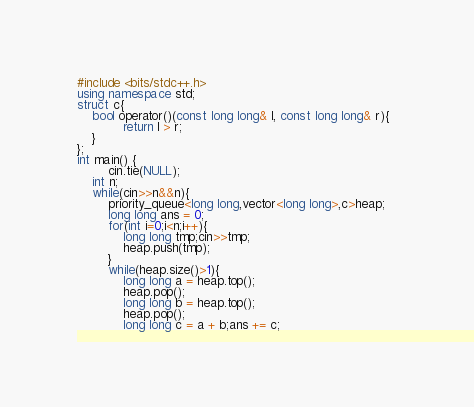<code> <loc_0><loc_0><loc_500><loc_500><_C++_>#include <bits/stdc++.h>
using namespace std;
struct c{
	bool operator()(const long long& l, const long long& r){  
       		return l > r;  
	}
};
int main() {
    	cin.tie(NULL);	
	int n;
	while(cin>>n&&n){
		priority_queue<long long,vector<long long>,c>heap;
		long long ans = 0;
		for(int i=0;i<n;i++){
			long long tmp;cin>>tmp;
			heap.push(tmp);
		}
		while(heap.size()>1){
			long long a = heap.top();
			heap.pop();
			long long b = heap.top();
			heap.pop();
			long long c = a + b;ans += c;</code> 